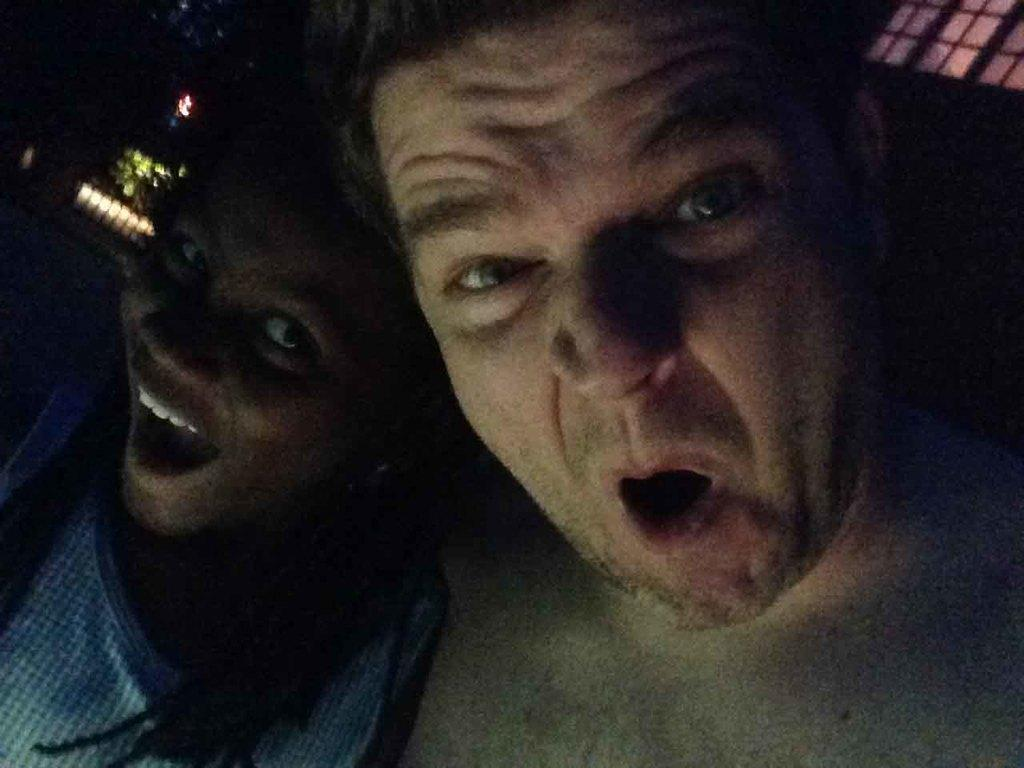How many people are in the image? There are two persons in the image. What are the persons doing in the image? The persons appear to be shouting and posing for the picture. Where are the lights located in the image? The lights are on the left side of the image. Can you see a kitty playing with the elbow of one of the persons in the image? There is no kitty or elbow interaction present in the image. 